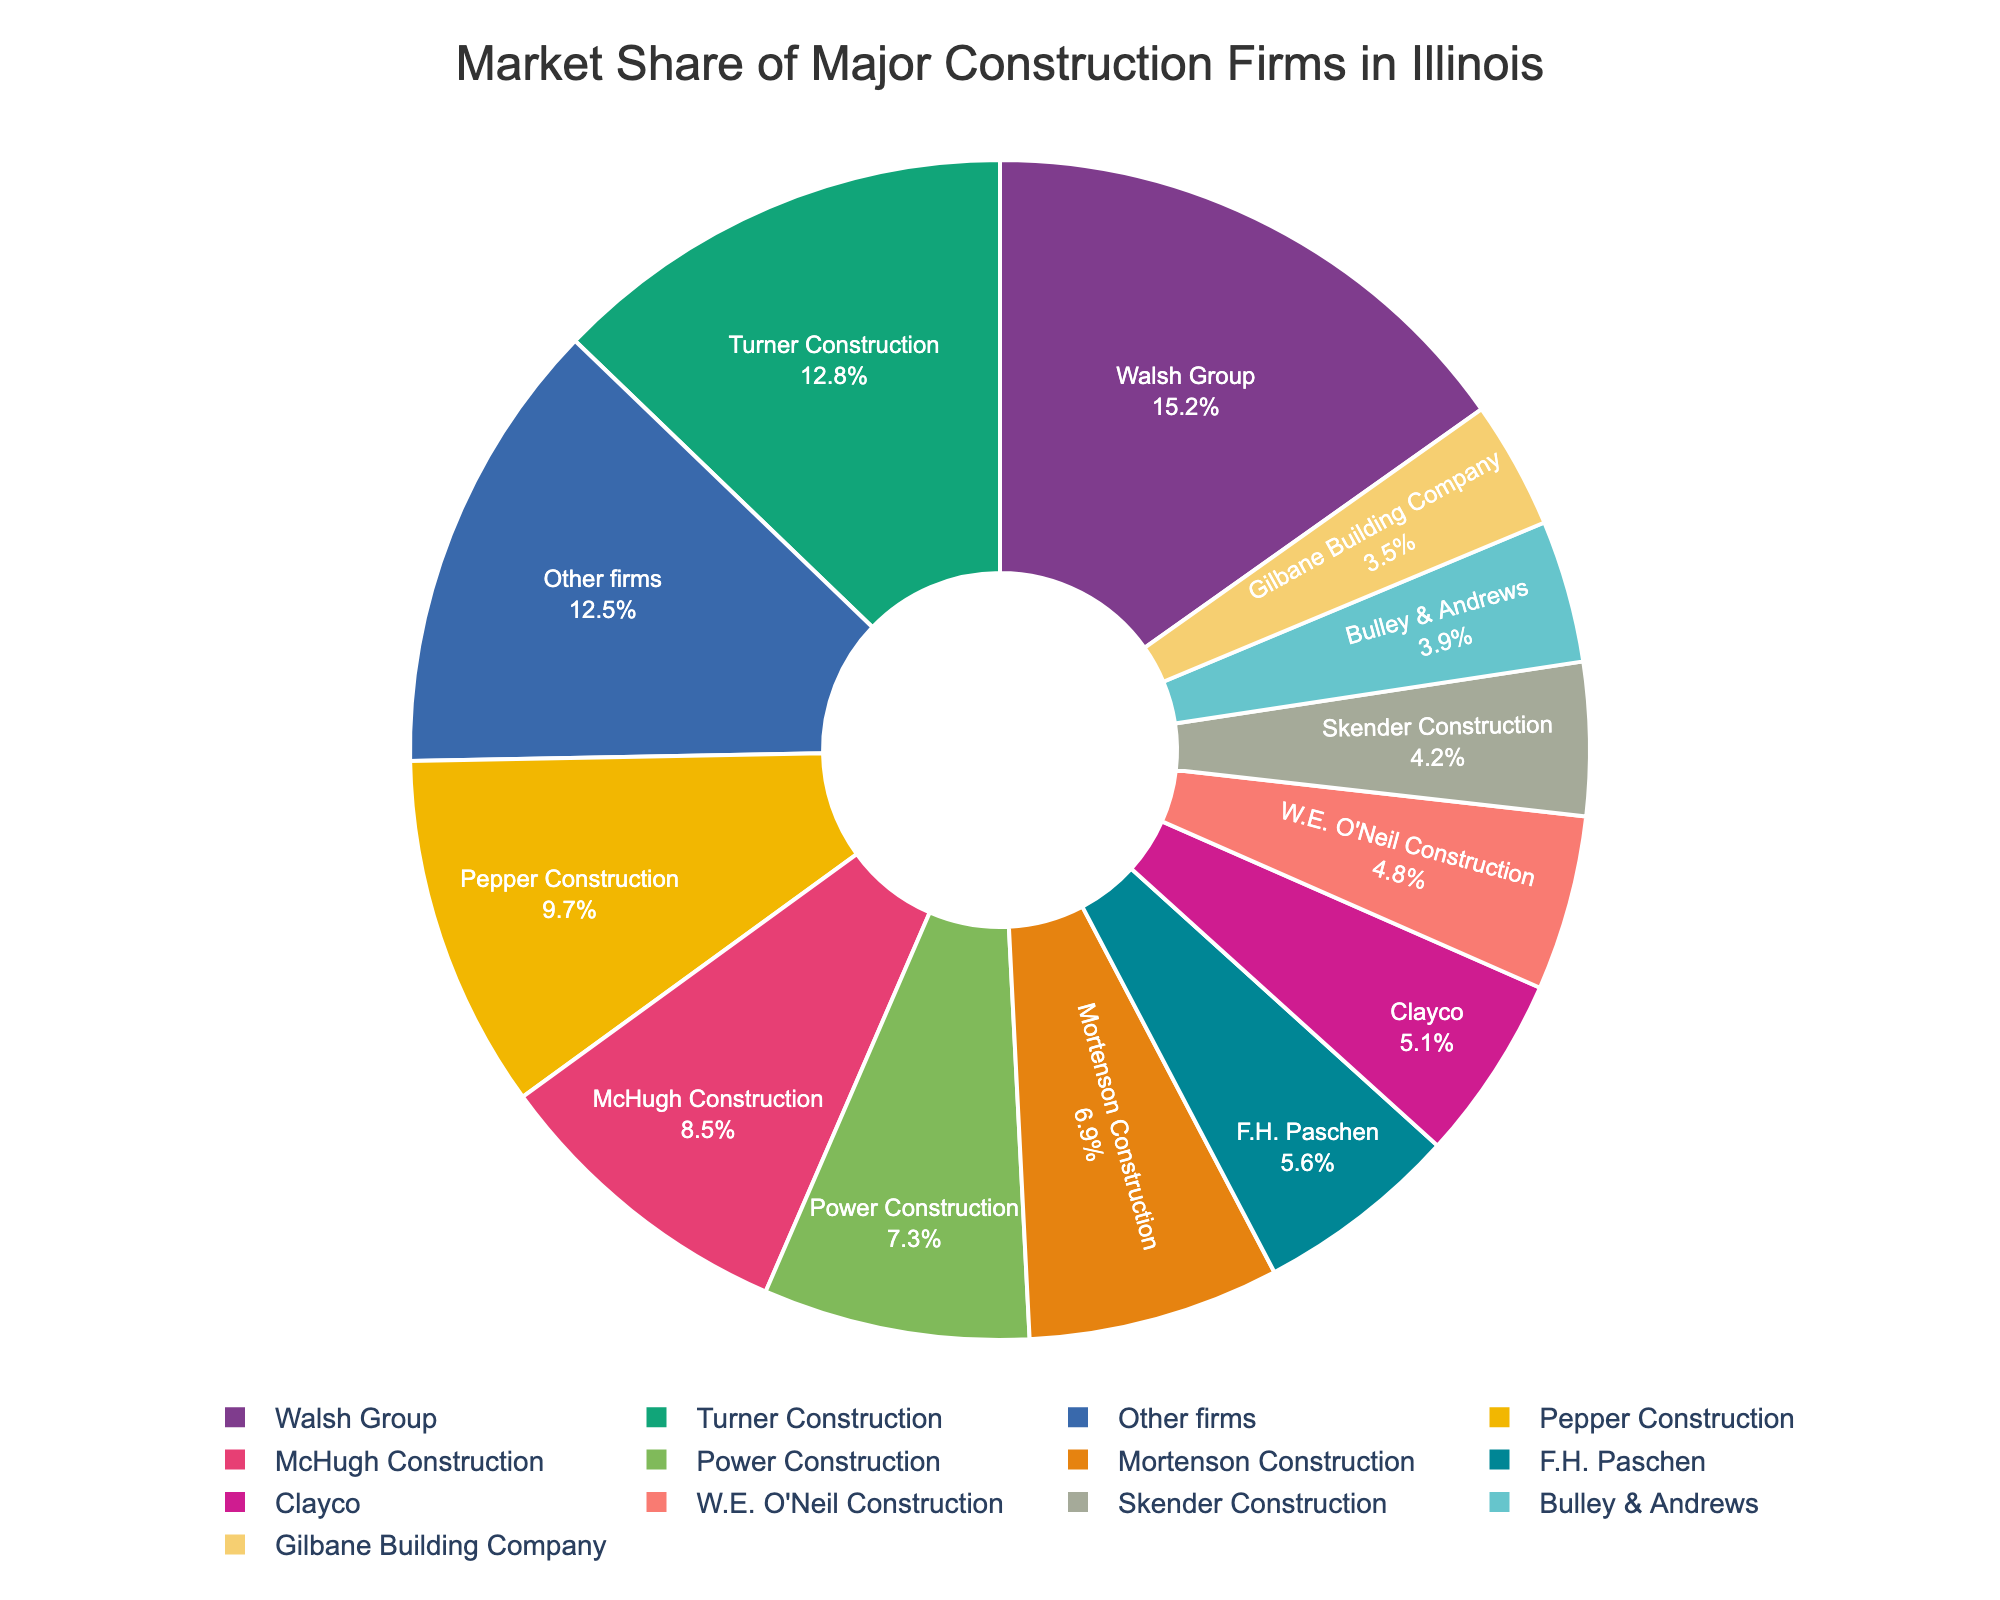What is the market share of Walsh Group? Referring to the chart's labels or segments, Walsh Group has a market share percentage displayed on its segment.
Answer: 15.2% Which company has the least market share? Referring to the chart, we look for the smallest segment or label, which indicates the smallest market share.
Answer: Gilbane Building Company What is the total market share of McHugh Construction and Pepper Construction combined? McHugh Construction has a market share of 8.5% and Pepper Construction has 9.7%. Adding these values, 8.5 + 9.7 = 18.2%.
Answer: 18.2% How many companies, including "Other firms," have a market share above 5%? By referring to the labels and their corresponding market share percentages, we count the companies with more than 5% share: Walsh Group, Turner Construction, Pepper Construction, McHugh Construction, Power Construction, Mortenson Construction, F.H. Paschen, and Other firms.
Answer: 8 Which color represents Pepper Construction? Identify the segment labeled "Pepper Construction" and observe its color on the pie chart.
Answer: **With the color information, we can only say** one of the custom color palette from px.colors.qualitative.Bold or px.colors.qualitative.Pastel Which company's market share is closest to 7%? By comparing the market share values, we identify that Power Construction has a market share of 7.3%, which is closest to 7%.
Answer: Power Construction What is the difference in market share between Turner Construction and Skender Construction? Turner Construction has a market share of 12.8%, and Skender Construction has 4.2%. We subtract the smaller from the larger, i.e., 12.8 - 4.2 = 8.6%.
Answer: 8.6% What is the average market share of the top three firms? The top three firms are Walsh Group (15.2%), Turner Construction (12.8%), and Pepper Construction (9.7%). Summing these: 15.2 + 12.8 + 9.7 = 37.7%. Dividing by 3, the average is 37.7 / 3 ≈ 12.57%.
Answer: 12.57% Which segment has the most substantial proportional area visually? The largest segment visually corresponds to the company with the highest market share.
Answer: Walsh Group What is the collective market share of companies with less than 5% each? Companies with less than 5% share are Clayco (5.1% is excluded), W.E. O'Neil Construction (4.8%), Skender Construction (4.2%), Bulley & Andrews (3.9%), and Gilbane Building Company (3.5%). Summing these: 4.8 + 4.2 + 3.9 + 3.5 = 16.4%.
Answer: 16.4% 